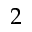Convert formula to latex. <formula><loc_0><loc_0><loc_500><loc_500>2</formula> 